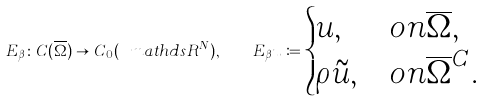<formula> <loc_0><loc_0><loc_500><loc_500>E _ { \beta } \colon C ( \overline { \Omega } ) \to C _ { 0 } ( \ m a t h d s { R } ^ { N } ) , \quad E _ { \beta } u \coloneqq \begin{cases} u , & o n \overline { \Omega } , \\ \rho \tilde { u } , & o n \overline { \Omega } ^ { C } . \end{cases}</formula> 